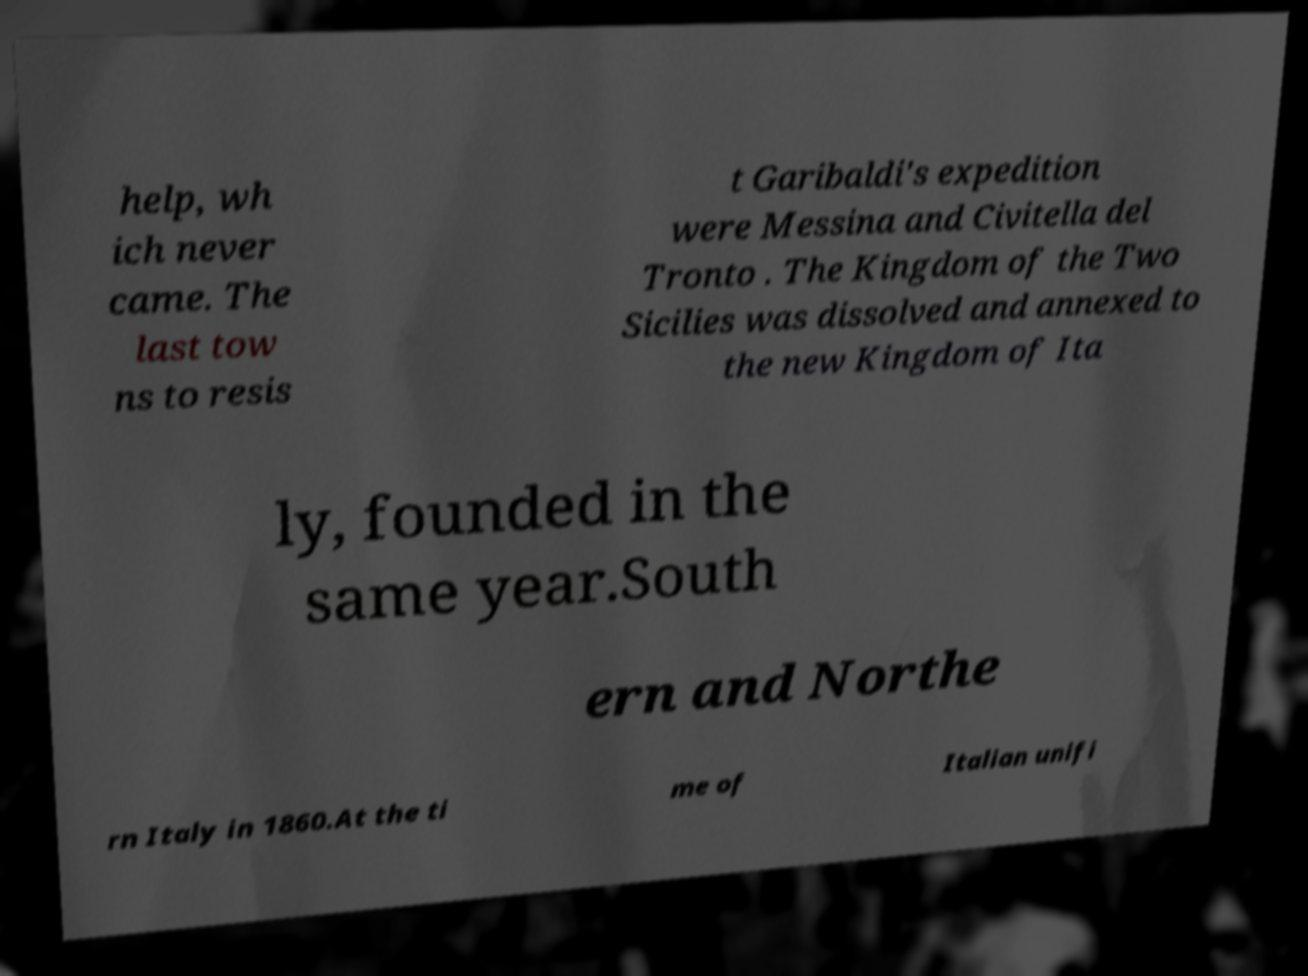Could you extract and type out the text from this image? help, wh ich never came. The last tow ns to resis t Garibaldi's expedition were Messina and Civitella del Tronto . The Kingdom of the Two Sicilies was dissolved and annexed to the new Kingdom of Ita ly, founded in the same year.South ern and Northe rn Italy in 1860.At the ti me of Italian unifi 